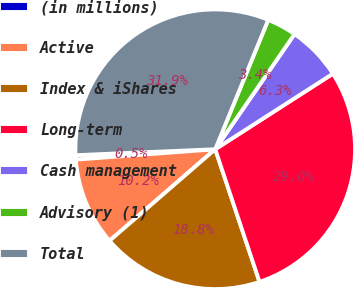Convert chart. <chart><loc_0><loc_0><loc_500><loc_500><pie_chart><fcel>(in millions)<fcel>Active<fcel>Index & iShares<fcel>Long-term<fcel>Cash management<fcel>Advisory (1)<fcel>Total<nl><fcel>0.5%<fcel>10.18%<fcel>18.77%<fcel>28.96%<fcel>6.32%<fcel>3.41%<fcel>31.87%<nl></chart> 